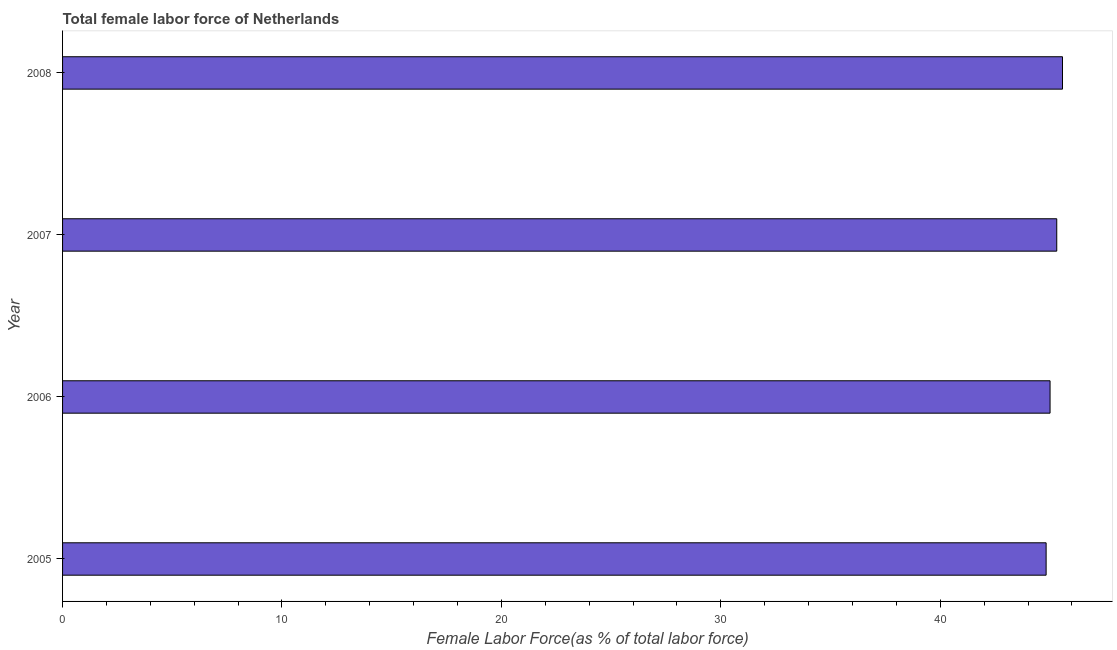What is the title of the graph?
Keep it short and to the point. Total female labor force of Netherlands. What is the label or title of the X-axis?
Give a very brief answer. Female Labor Force(as % of total labor force). What is the label or title of the Y-axis?
Provide a succinct answer. Year. What is the total female labor force in 2007?
Make the answer very short. 45.31. Across all years, what is the maximum total female labor force?
Your answer should be very brief. 45.57. Across all years, what is the minimum total female labor force?
Your answer should be compact. 44.83. In which year was the total female labor force maximum?
Keep it short and to the point. 2008. What is the sum of the total female labor force?
Offer a terse response. 180.71. What is the difference between the total female labor force in 2005 and 2008?
Offer a terse response. -0.75. What is the average total female labor force per year?
Offer a very short reply. 45.18. What is the median total female labor force?
Provide a short and direct response. 45.16. In how many years, is the total female labor force greater than 38 %?
Your response must be concise. 4. Do a majority of the years between 2006 and 2005 (inclusive) have total female labor force greater than 16 %?
Give a very brief answer. No. What is the difference between the highest and the second highest total female labor force?
Offer a terse response. 0.26. Is the sum of the total female labor force in 2005 and 2007 greater than the maximum total female labor force across all years?
Provide a succinct answer. Yes. Are all the bars in the graph horizontal?
Offer a terse response. Yes. Are the values on the major ticks of X-axis written in scientific E-notation?
Your answer should be compact. No. What is the Female Labor Force(as % of total labor force) in 2005?
Your answer should be very brief. 44.83. What is the Female Labor Force(as % of total labor force) of 2006?
Provide a succinct answer. 45.01. What is the Female Labor Force(as % of total labor force) of 2007?
Provide a short and direct response. 45.31. What is the Female Labor Force(as % of total labor force) of 2008?
Your answer should be very brief. 45.57. What is the difference between the Female Labor Force(as % of total labor force) in 2005 and 2006?
Ensure brevity in your answer.  -0.18. What is the difference between the Female Labor Force(as % of total labor force) in 2005 and 2007?
Your answer should be compact. -0.48. What is the difference between the Female Labor Force(as % of total labor force) in 2005 and 2008?
Your response must be concise. -0.75. What is the difference between the Female Labor Force(as % of total labor force) in 2006 and 2007?
Your answer should be very brief. -0.31. What is the difference between the Female Labor Force(as % of total labor force) in 2006 and 2008?
Your answer should be very brief. -0.57. What is the difference between the Female Labor Force(as % of total labor force) in 2007 and 2008?
Give a very brief answer. -0.26. What is the ratio of the Female Labor Force(as % of total labor force) in 2005 to that in 2006?
Keep it short and to the point. 1. What is the ratio of the Female Labor Force(as % of total labor force) in 2006 to that in 2007?
Your answer should be compact. 0.99. What is the ratio of the Female Labor Force(as % of total labor force) in 2006 to that in 2008?
Your answer should be compact. 0.99. 